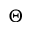<formula> <loc_0><loc_0><loc_500><loc_500>\Theta</formula> 